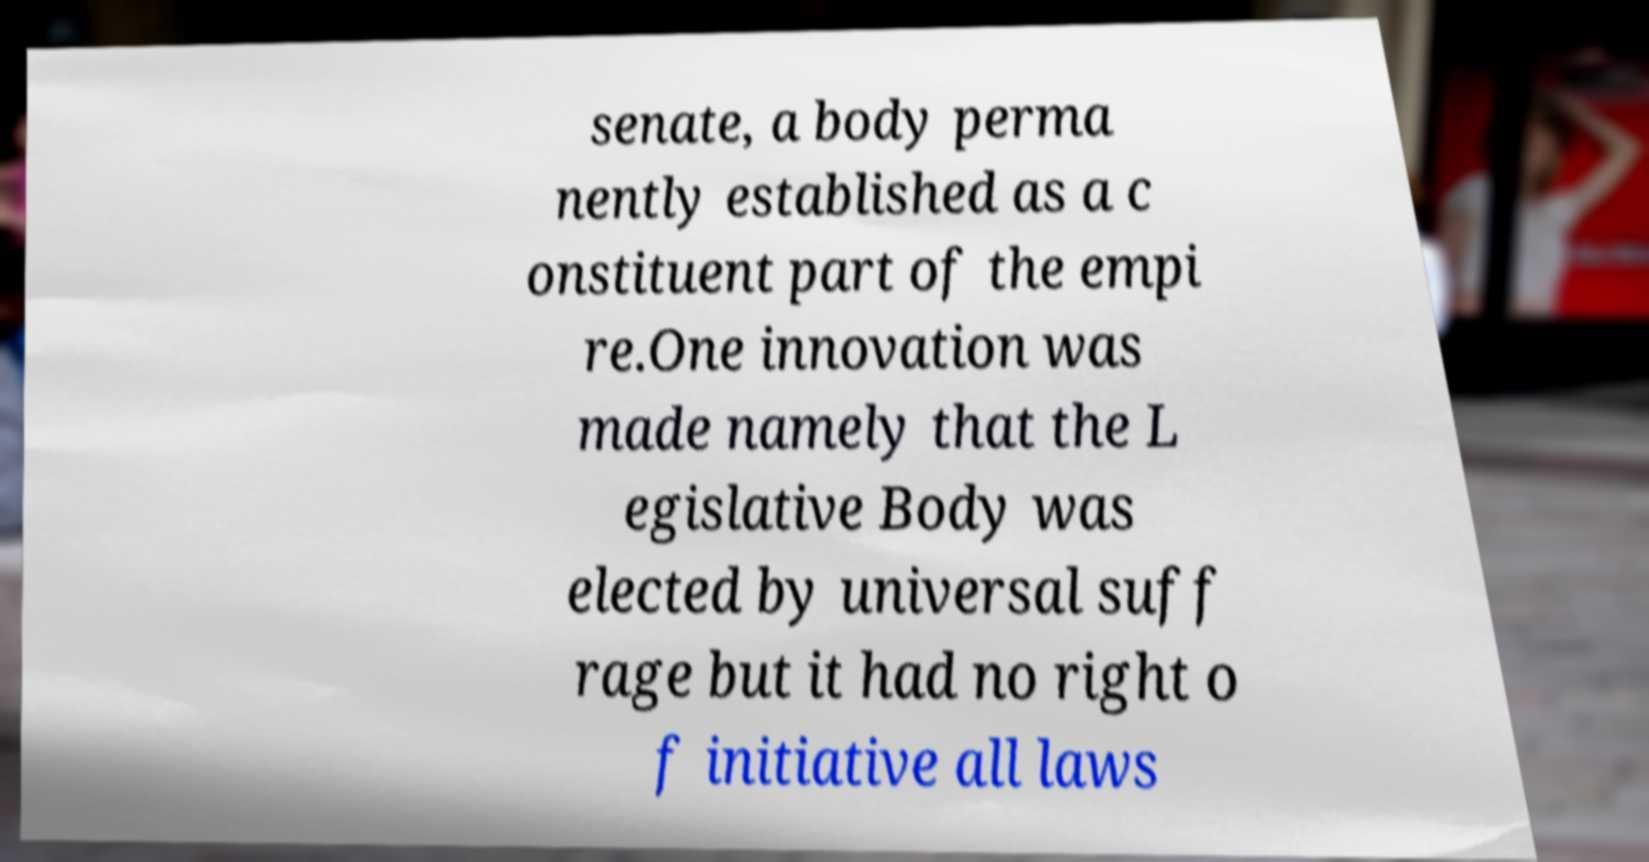Please identify and transcribe the text found in this image. senate, a body perma nently established as a c onstituent part of the empi re.One innovation was made namely that the L egislative Body was elected by universal suff rage but it had no right o f initiative all laws 